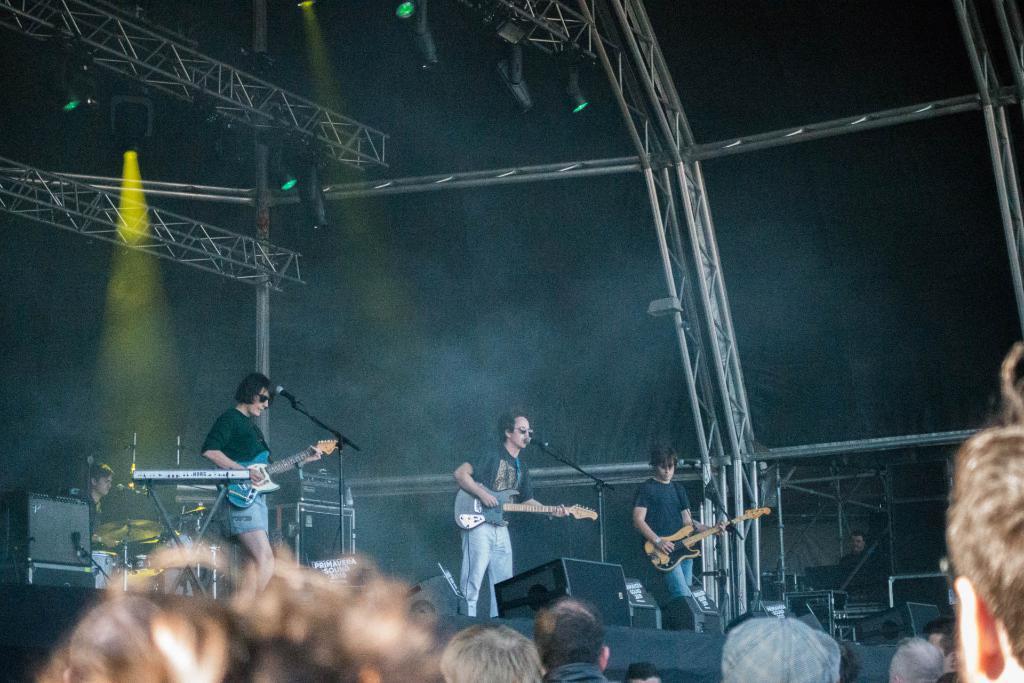How would you summarize this image in a sentence or two? In the given image we can see there is a consort going on. There are three too four people on stage performing and there are audience who are watching them. 